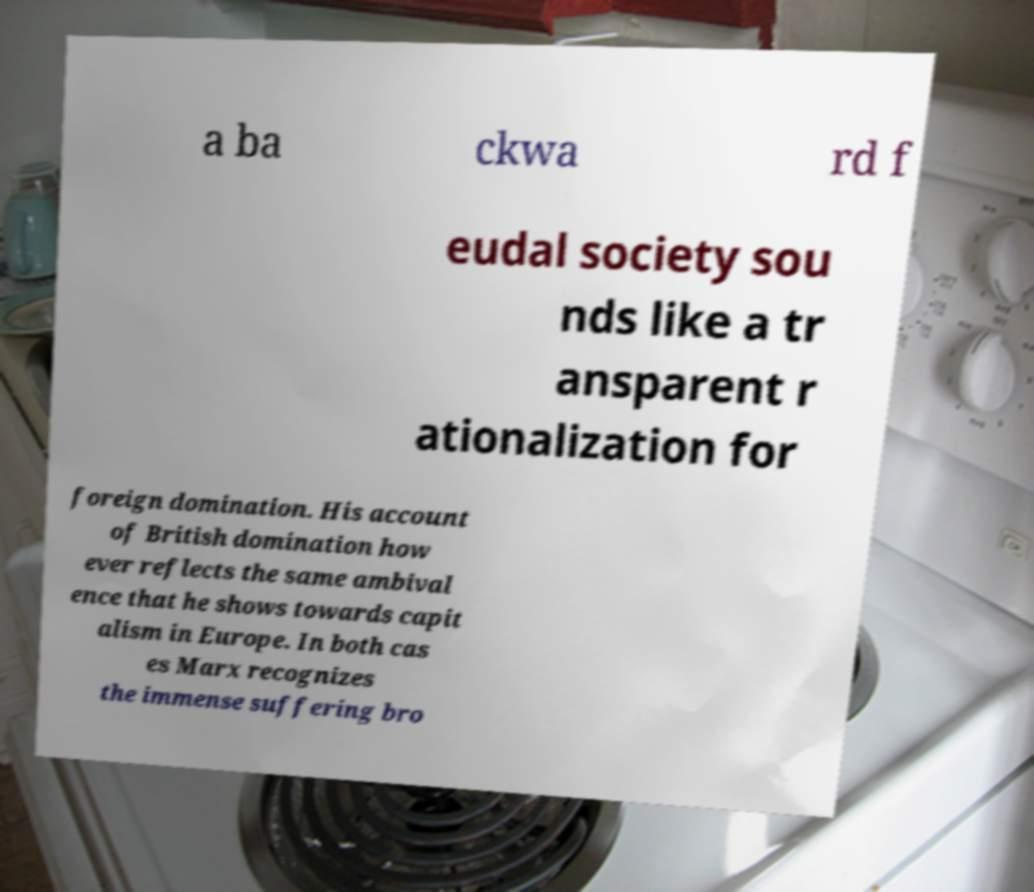Please read and relay the text visible in this image. What does it say? a ba ckwa rd f eudal society sou nds like a tr ansparent r ationalization for foreign domination. His account of British domination how ever reflects the same ambival ence that he shows towards capit alism in Europe. In both cas es Marx recognizes the immense suffering bro 